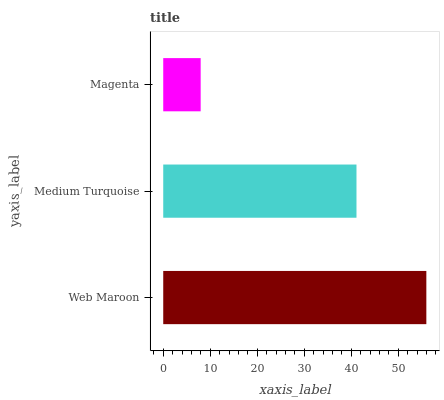Is Magenta the minimum?
Answer yes or no. Yes. Is Web Maroon the maximum?
Answer yes or no. Yes. Is Medium Turquoise the minimum?
Answer yes or no. No. Is Medium Turquoise the maximum?
Answer yes or no. No. Is Web Maroon greater than Medium Turquoise?
Answer yes or no. Yes. Is Medium Turquoise less than Web Maroon?
Answer yes or no. Yes. Is Medium Turquoise greater than Web Maroon?
Answer yes or no. No. Is Web Maroon less than Medium Turquoise?
Answer yes or no. No. Is Medium Turquoise the high median?
Answer yes or no. Yes. Is Medium Turquoise the low median?
Answer yes or no. Yes. Is Web Maroon the high median?
Answer yes or no. No. Is Magenta the low median?
Answer yes or no. No. 